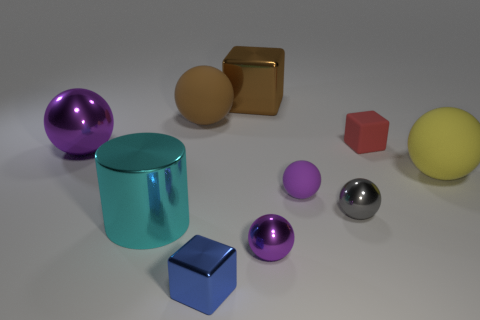How many purple spheres must be subtracted to get 1 purple spheres? 2 Subtract all cyan cylinders. How many purple spheres are left? 3 Subtract all yellow balls. How many balls are left? 5 Subtract all yellow spheres. How many spheres are left? 5 Subtract all cyan balls. Subtract all gray cubes. How many balls are left? 6 Subtract all blocks. How many objects are left? 7 Add 2 green metallic cubes. How many green metallic cubes exist? 2 Subtract 0 green balls. How many objects are left? 10 Subtract all big brown cubes. Subtract all tiny matte balls. How many objects are left? 8 Add 4 large purple spheres. How many large purple spheres are left? 5 